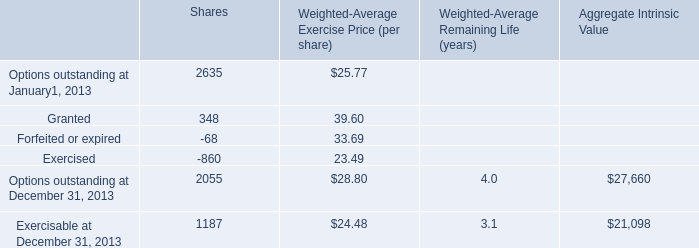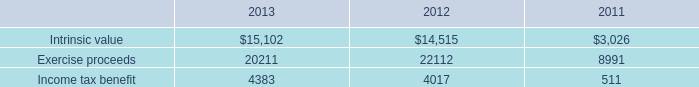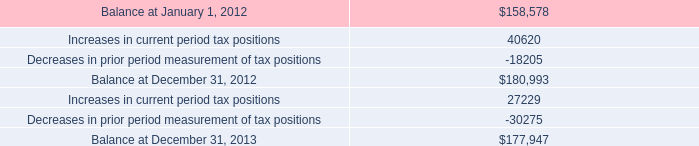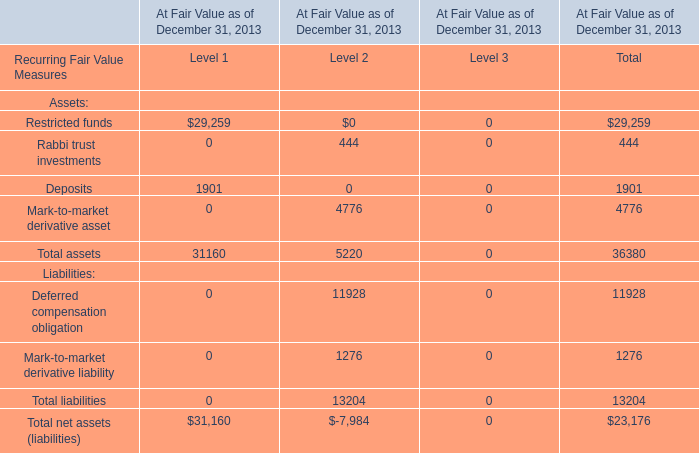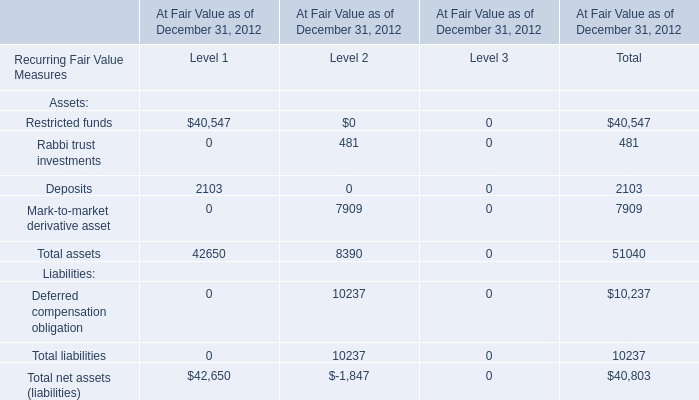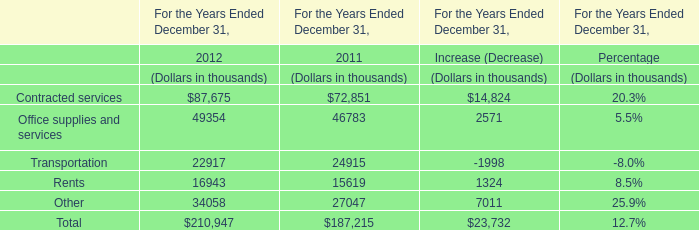Which element makes up more than 1 % of the total in 2012? 
Answer: Restricted funds, Mark-to-market derivative asset. 